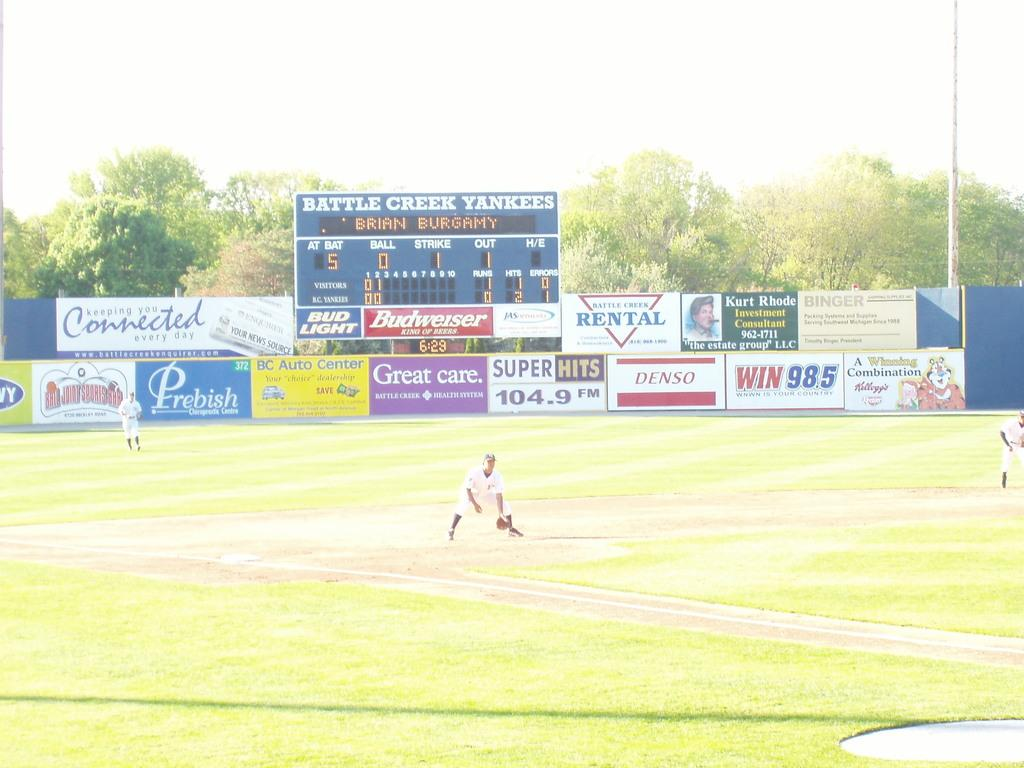<image>
Render a clear and concise summary of the photo. Baseball stadium that has a scoreboard that says Battle Creek Yankees. 